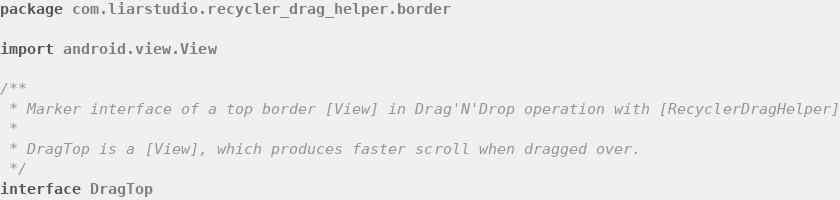Convert code to text. <code><loc_0><loc_0><loc_500><loc_500><_Kotlin_>package com.liarstudio.recycler_drag_helper.border

import android.view.View

/**
 * Marker interface of a top border [View] in Drag'N'Drop operation with [RecyclerDragHelper]
 *
 * DragTop is a [View], which produces faster scroll when dragged over.
 */
interface DragTop
</code> 